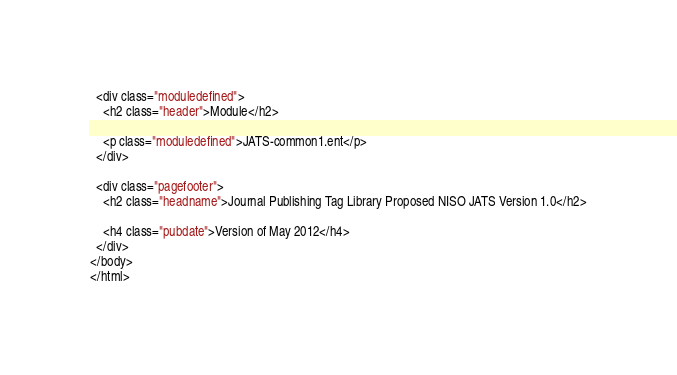<code> <loc_0><loc_0><loc_500><loc_500><_HTML_>
  <div class="moduledefined">
    <h2 class="header">Module</h2>

    <p class="moduledefined">JATS-common1.ent</p>
  </div>

  <div class="pagefooter">
    <h2 class="headname">Journal Publishing Tag Library Proposed NISO JATS Version 1.0</h2>

    <h4 class="pubdate">Version of May 2012</h4>
  </div>
</body>
</html>
</code> 